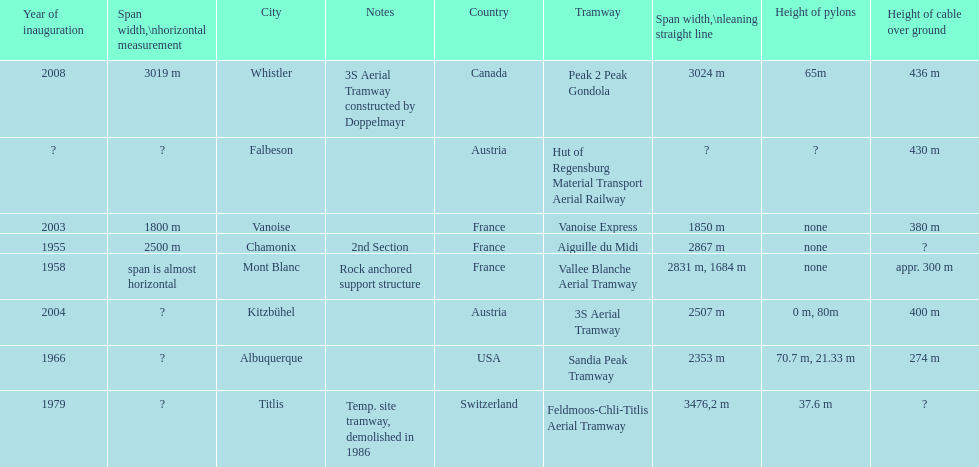How much greater is the height of cable over ground measurement for the peak 2 peak gondola when compared with that of the vanoise express? 56 m. 